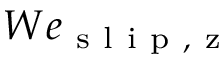Convert formula to latex. <formula><loc_0><loc_0><loc_500><loc_500>W e _ { s l i p , z }</formula> 